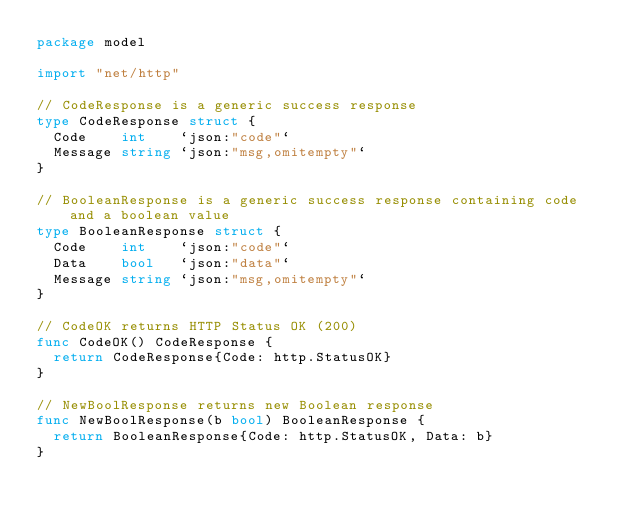Convert code to text. <code><loc_0><loc_0><loc_500><loc_500><_Go_>package model

import "net/http"

// CodeResponse is a generic success response
type CodeResponse struct {
	Code    int    `json:"code"`
	Message string `json:"msg,omitempty"`
}

// BooleanResponse is a generic success response containing code and a boolean value
type BooleanResponse struct {
	Code    int    `json:"code"`
	Data    bool   `json:"data"`
	Message string `json:"msg,omitempty"`
}

// CodeOK returns HTTP Status OK (200)
func CodeOK() CodeResponse {
	return CodeResponse{Code: http.StatusOK}
}

// NewBoolResponse returns new Boolean response
func NewBoolResponse(b bool) BooleanResponse {
	return BooleanResponse{Code: http.StatusOK, Data: b}
}
</code> 